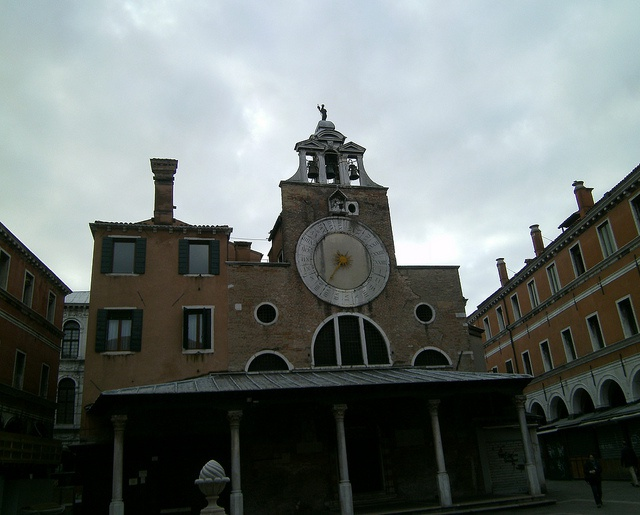Describe the objects in this image and their specific colors. I can see clock in darkgray, gray, and black tones and people in black, darkgreen, and darkgray tones in this image. 